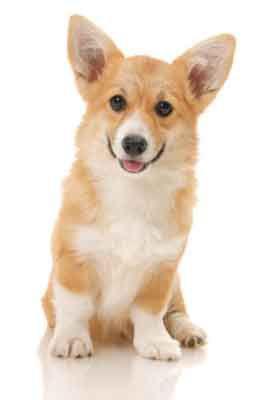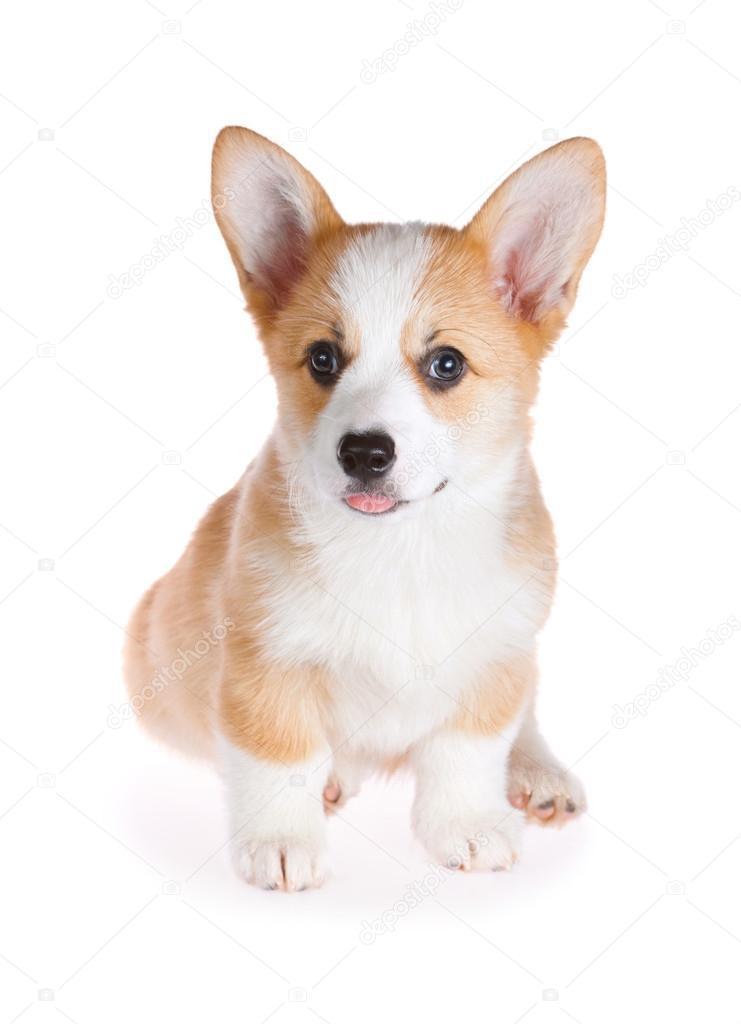The first image is the image on the left, the second image is the image on the right. Analyze the images presented: Is the assertion "At least one dog has its mouth completely closed." valid? Answer yes or no. No. The first image is the image on the left, the second image is the image on the right. Analyze the images presented: Is the assertion "Right image shows one short-legged dog standing outdoors." valid? Answer yes or no. No. 